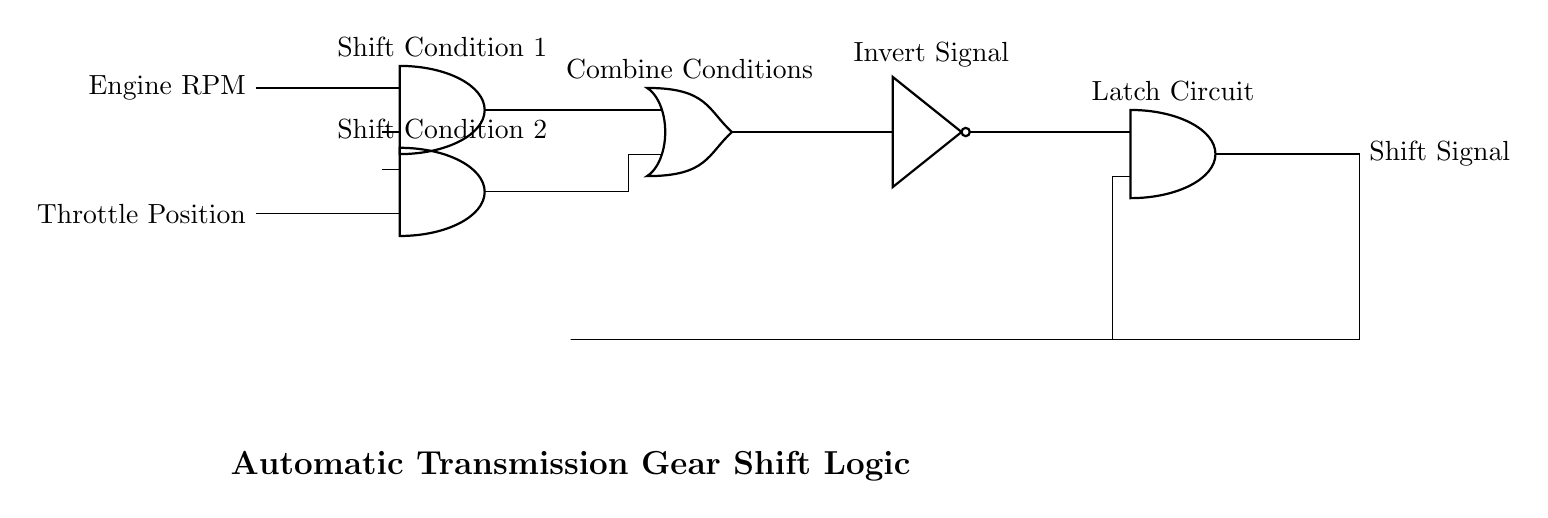What inputs are used in this logic circuit? The inputs in this logic circuit are Engine RPM and Throttle Position, which are introduced on the left side of the circuit.
Answer: Engine RPM, Throttle Position What type of gates are present in this circuit? The circuit includes AND gates, OR gates, and a NOT gate, identifiable by their symbols and connections.
Answer: AND, OR, NOT What does the "Combine Conditions" section indicate? The "Combine Conditions" section indicates that multiple conditions from the input gates are being processed together by the OR gate to produce a single output signal.
Answer: OR gate output What is the purpose of the NOT gate in this circuit? The NOT gate's purpose is to invert the signal coming from the OR gate, altering the output state based on its input, which is essential for managing the shift signal logic.
Answer: Invert signal How does the feedback loop function in this circuit? The feedback loop connects the output of the latch circuit back into its input, which allows the circuit to remember the previous state, ensuring stable operation during gear shifting.
Answer: Remembers the previous state What is the significance of the "Shift Signal" output? The "Shift Signal" output represents the final command to initiate a gear shift, which is crucial for the functioning of the automatic transmission system according to the processed conditions.
Answer: Gear shift command 